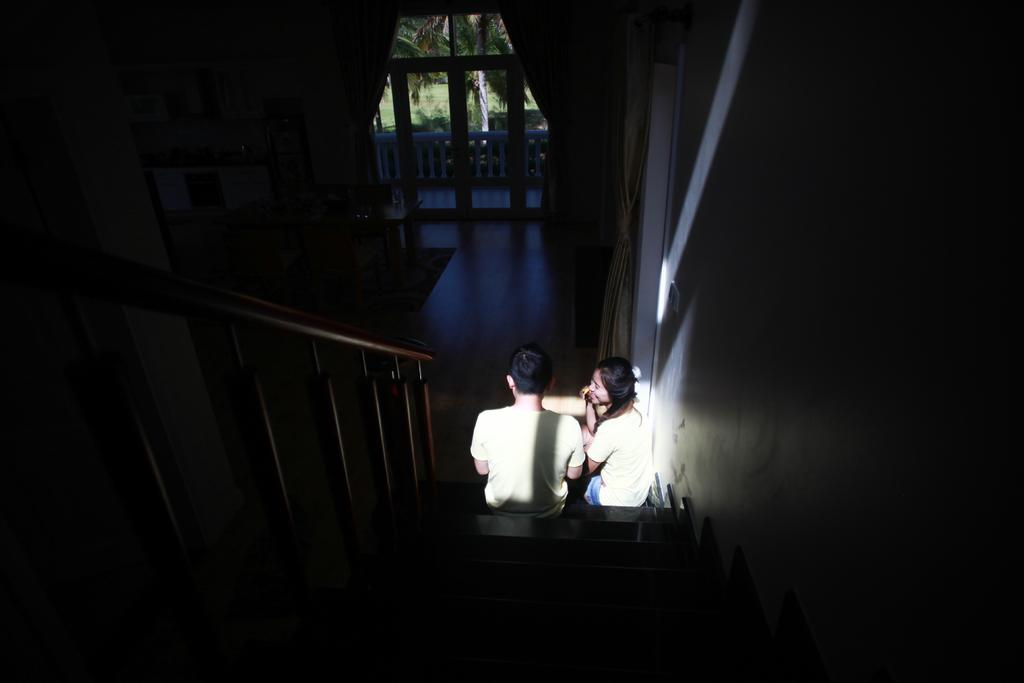What is the overall lighting condition in the image? The image is dark. How many people are present in the image? There are two people sitting in the image. Can you describe one of the individuals in the image? One of the people is a woman. What is located beside the woman? There is a wall beside the woman. What can be seen in the background of the image? There is a fence and a tree in the background of the image. What type of net is being used by the woman in the image? There is no net present in the image. What color is the woman's sock in the image? There is no sock visible in the image. 